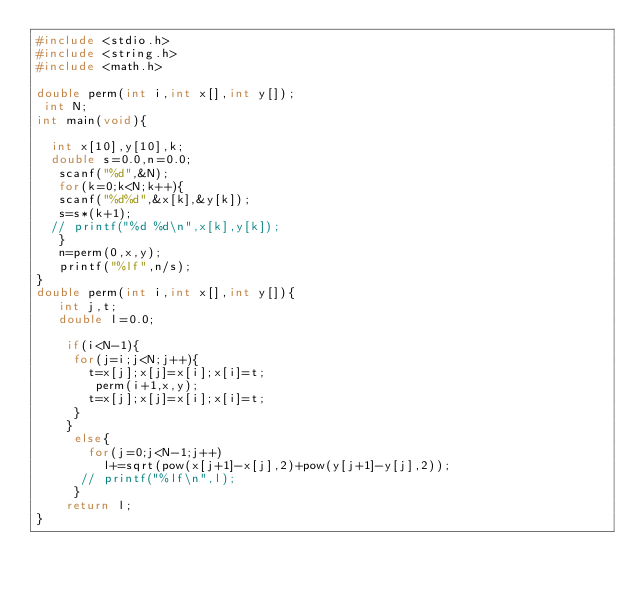<code> <loc_0><loc_0><loc_500><loc_500><_C_>#include <stdio.h>
#include <string.h>
#include <math.h>
  
double perm(int i,int x[],int y[]);
 int N;
int main(void){
    
  int x[10],y[10],k;
  double s=0.0,n=0.0;
   scanf("%d",&N);
   for(k=0;k<N;k++){
   scanf("%d%d",&x[k],&y[k]);
   s=s*(k+1);
  // printf("%d %d\n",x[k],y[k]);
   }
   n=perm(0,x,y);
   printf("%lf",n/s);
}
double perm(int i,int x[],int y[]){
   int j,t;
   double l=0.0;
     
    if(i<N-1){
     for(j=i;j<N;j++){
       t=x[j];x[j]=x[i];x[i]=t;
        perm(i+1,x,y);
       t=x[j];x[j]=x[i];x[i]=t;
     }
    }
     else{
       for(j=0;j<N-1;j++)
         l+=sqrt(pow(x[j+1]-x[j],2)+pow(y[j+1]-y[j],2));
      // printf("%lf\n",l);
     }
    return l;     
}</code> 